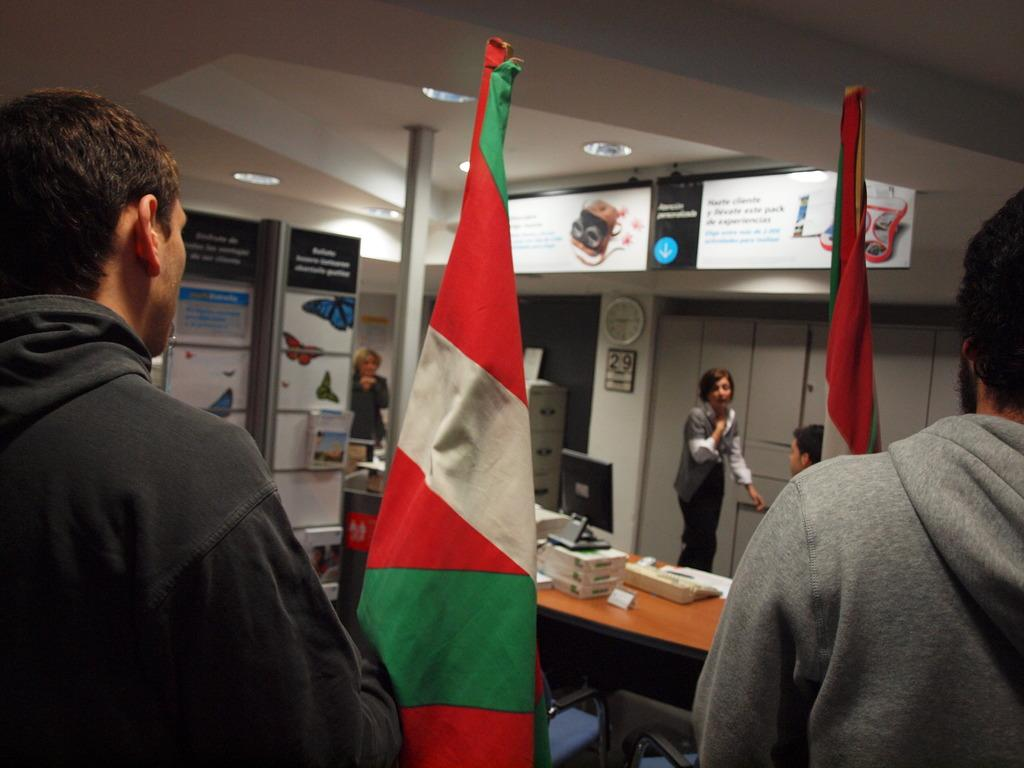How many people are present in the image? There are 5 persons in the image. What can be seen related to national symbols in the image? There are 2 flags in the image. What type of objects are present in the image that might be used for displaying information or art? There are boards and pictures in the image. What piece of furniture is visible in the image? There is a table in the image. What is on top of the table in the image? There are things on the table. What time-telling device is visible in the image? There is a clock on the wall. What type of game is being played by the persons in the image? There is no indication of a game being played in the image; the focus is on the people, flags, boards, pictures, table, and clock. 